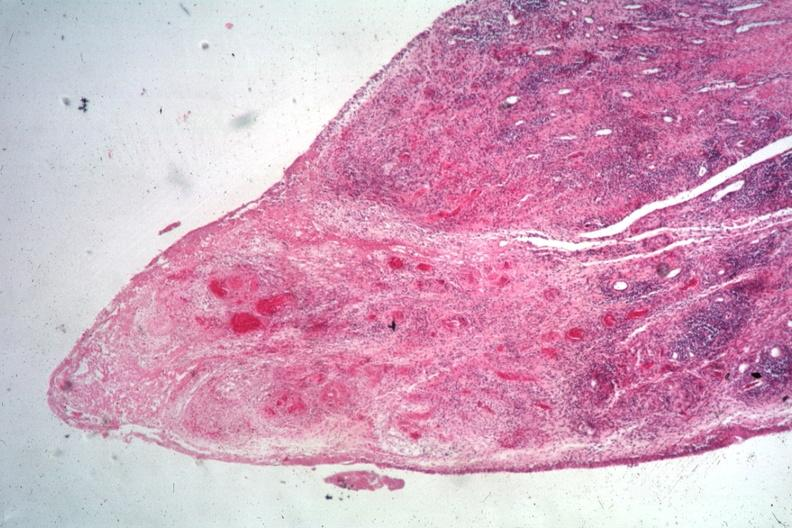s peritoneal surface of uterus and douglas pouch outstanding photo primary present?
Answer the question using a single word or phrase. No 